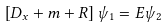<formula> <loc_0><loc_0><loc_500><loc_500>\left [ D _ { x } + m + R \right ] \psi _ { 1 } = E \psi _ { 2 }</formula> 